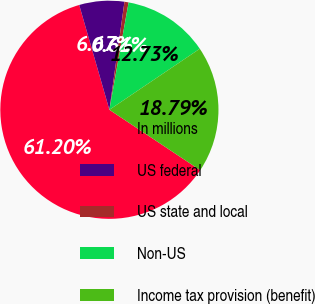Convert chart to OTSL. <chart><loc_0><loc_0><loc_500><loc_500><pie_chart><fcel>In millions<fcel>US federal<fcel>US state and local<fcel>Non-US<fcel>Income tax provision (benefit)<nl><fcel>61.2%<fcel>6.67%<fcel>0.61%<fcel>12.73%<fcel>18.79%<nl></chart> 